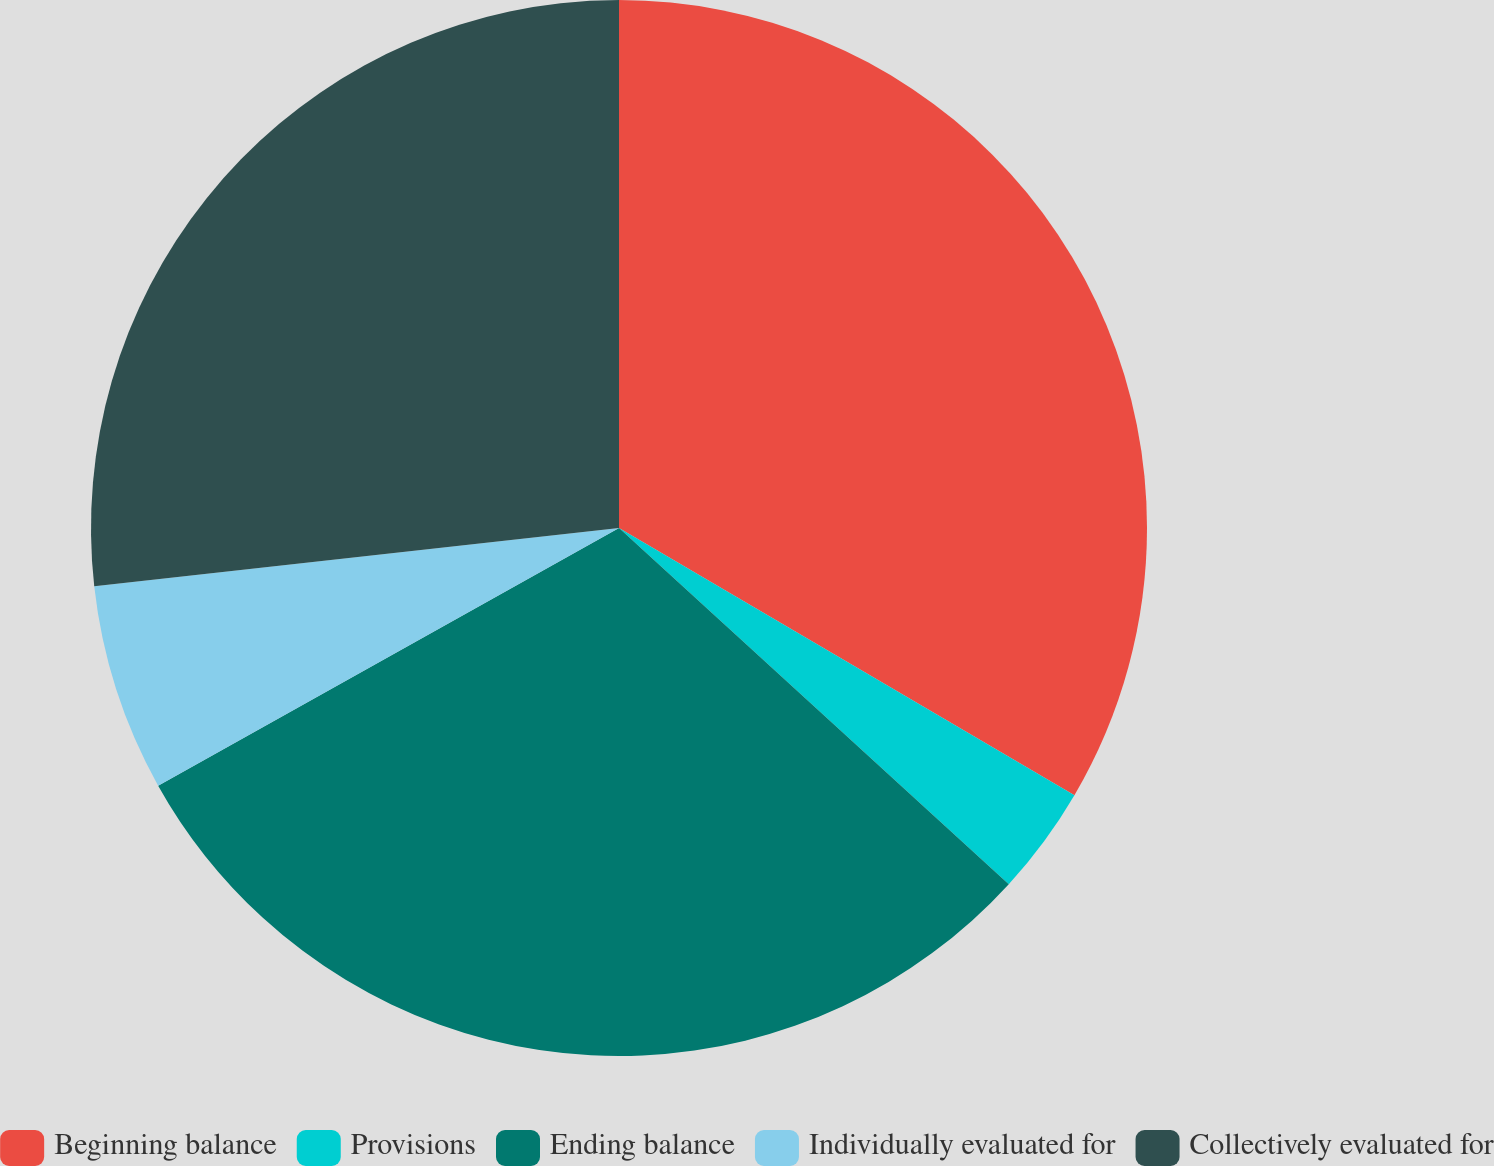<chart> <loc_0><loc_0><loc_500><loc_500><pie_chart><fcel>Beginning balance<fcel>Provisions<fcel>Ending balance<fcel>Individually evaluated for<fcel>Collectively evaluated for<nl><fcel>33.44%<fcel>3.34%<fcel>30.1%<fcel>6.35%<fcel>26.76%<nl></chart> 